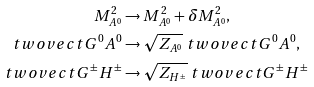<formula> <loc_0><loc_0><loc_500><loc_500>M _ { A ^ { 0 } } ^ { 2 } & \to M _ { A ^ { 0 } } ^ { 2 } + \delta M _ { A ^ { 0 } } ^ { 2 } , \\ \ t w o v e c t { G ^ { 0 } } { A ^ { 0 } } & \to \sqrt { Z _ { A ^ { 0 } } } \ t w o v e c t { G ^ { 0 } } { A ^ { 0 } } , \\ \ t w o v e c t { G ^ { \pm } } { H ^ { \pm } } & \to \sqrt { Z _ { H ^ { \pm } } } \ t w o v e c t { G ^ { \pm } } { H ^ { \pm } }</formula> 